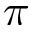<formula> <loc_0><loc_0><loc_500><loc_500>\pi</formula> 